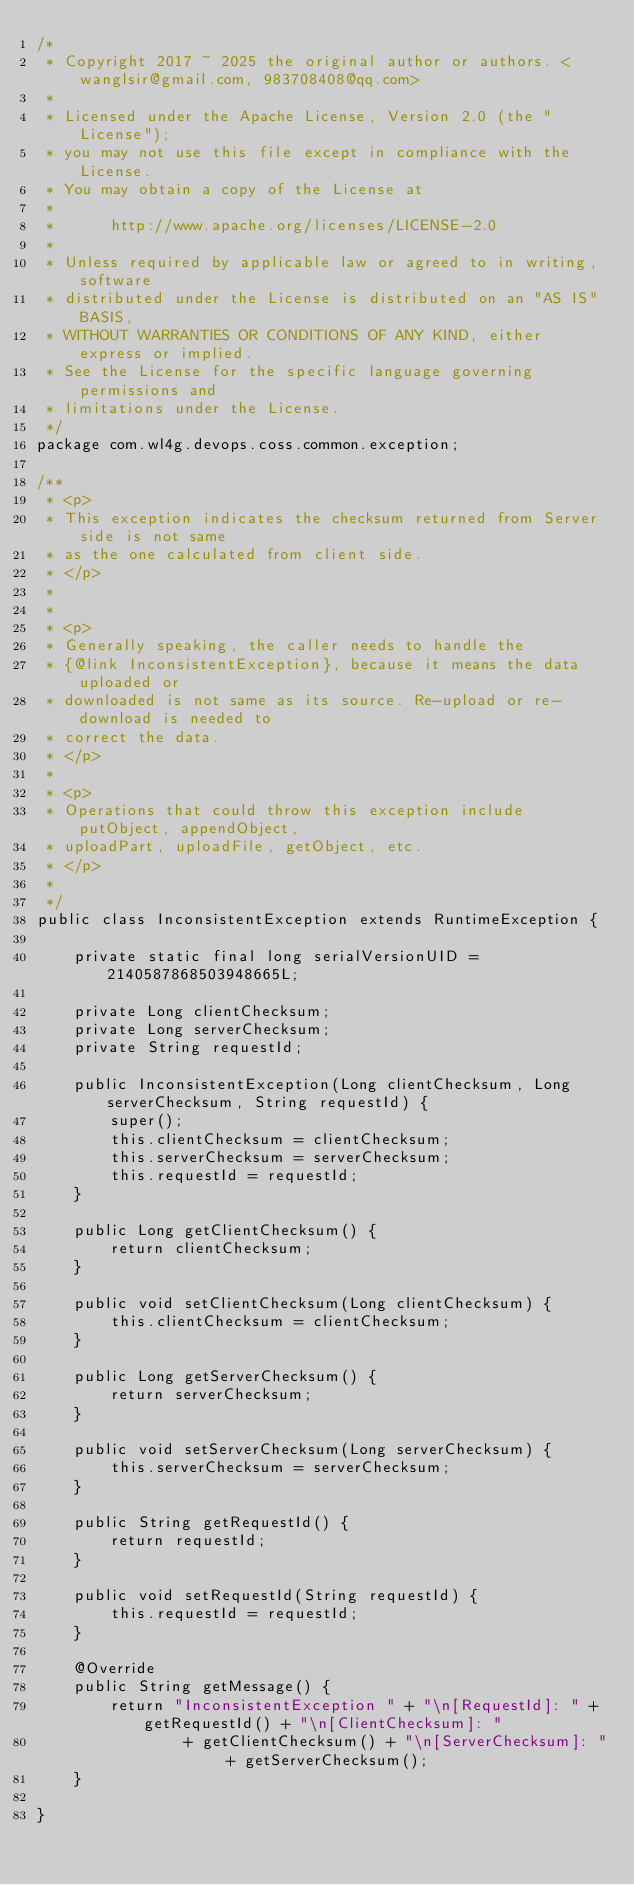<code> <loc_0><loc_0><loc_500><loc_500><_Java_>/*
 * Copyright 2017 ~ 2025 the original author or authors. <wanglsir@gmail.com, 983708408@qq.com>
 *
 * Licensed under the Apache License, Version 2.0 (the "License");
 * you may not use this file except in compliance with the License.
 * You may obtain a copy of the License at
 *
 *      http://www.apache.org/licenses/LICENSE-2.0
 *
 * Unless required by applicable law or agreed to in writing, software
 * distributed under the License is distributed on an "AS IS" BASIS,
 * WITHOUT WARRANTIES OR CONDITIONS OF ANY KIND, either express or implied.
 * See the License for the specific language governing permissions and
 * limitations under the License.
 */
package com.wl4g.devops.coss.common.exception;

/**
 * <p>
 * This exception indicates the checksum returned from Server side is not same
 * as the one calculated from client side.
 * </p>
 * 
 * 
 * <p>
 * Generally speaking, the caller needs to handle the
 * {@link InconsistentException}, because it means the data uploaded or
 * downloaded is not same as its source. Re-upload or re-download is needed to
 * correct the data.
 * </p>
 * 
 * <p>
 * Operations that could throw this exception include putObject, appendObject,
 * uploadPart, uploadFile, getObject, etc.
 * </p>
 * 
 */
public class InconsistentException extends RuntimeException {

    private static final long serialVersionUID = 2140587868503948665L;

    private Long clientChecksum;
    private Long serverChecksum;
    private String requestId;

    public InconsistentException(Long clientChecksum, Long serverChecksum, String requestId) {
        super();
        this.clientChecksum = clientChecksum;
        this.serverChecksum = serverChecksum;
        this.requestId = requestId;
    }

    public Long getClientChecksum() {
        return clientChecksum;
    }

    public void setClientChecksum(Long clientChecksum) {
        this.clientChecksum = clientChecksum;
    }

    public Long getServerChecksum() {
        return serverChecksum;
    }

    public void setServerChecksum(Long serverChecksum) {
        this.serverChecksum = serverChecksum;
    }

    public String getRequestId() {
        return requestId;
    }

    public void setRequestId(String requestId) {
        this.requestId = requestId;
    }

    @Override
    public String getMessage() {
        return "InconsistentException " + "\n[RequestId]: " + getRequestId() + "\n[ClientChecksum]: "
                + getClientChecksum() + "\n[ServerChecksum]: " + getServerChecksum();
    }

}</code> 